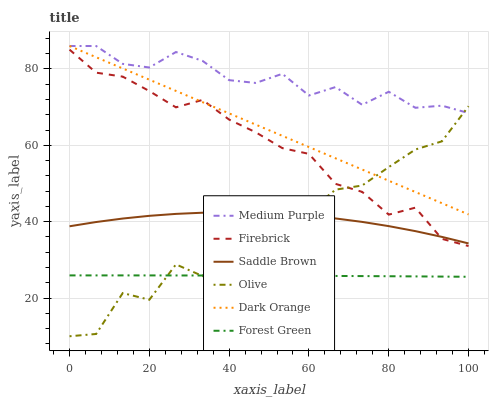Does Forest Green have the minimum area under the curve?
Answer yes or no. Yes. Does Medium Purple have the maximum area under the curve?
Answer yes or no. Yes. Does Firebrick have the minimum area under the curve?
Answer yes or no. No. Does Firebrick have the maximum area under the curve?
Answer yes or no. No. Is Dark Orange the smoothest?
Answer yes or no. Yes. Is Olive the roughest?
Answer yes or no. Yes. Is Firebrick the smoothest?
Answer yes or no. No. Is Firebrick the roughest?
Answer yes or no. No. Does Olive have the lowest value?
Answer yes or no. Yes. Does Firebrick have the lowest value?
Answer yes or no. No. Does Medium Purple have the highest value?
Answer yes or no. Yes. Does Firebrick have the highest value?
Answer yes or no. No. Is Firebrick less than Medium Purple?
Answer yes or no. Yes. Is Dark Orange greater than Saddle Brown?
Answer yes or no. Yes. Does Forest Green intersect Olive?
Answer yes or no. Yes. Is Forest Green less than Olive?
Answer yes or no. No. Is Forest Green greater than Olive?
Answer yes or no. No. Does Firebrick intersect Medium Purple?
Answer yes or no. No. 